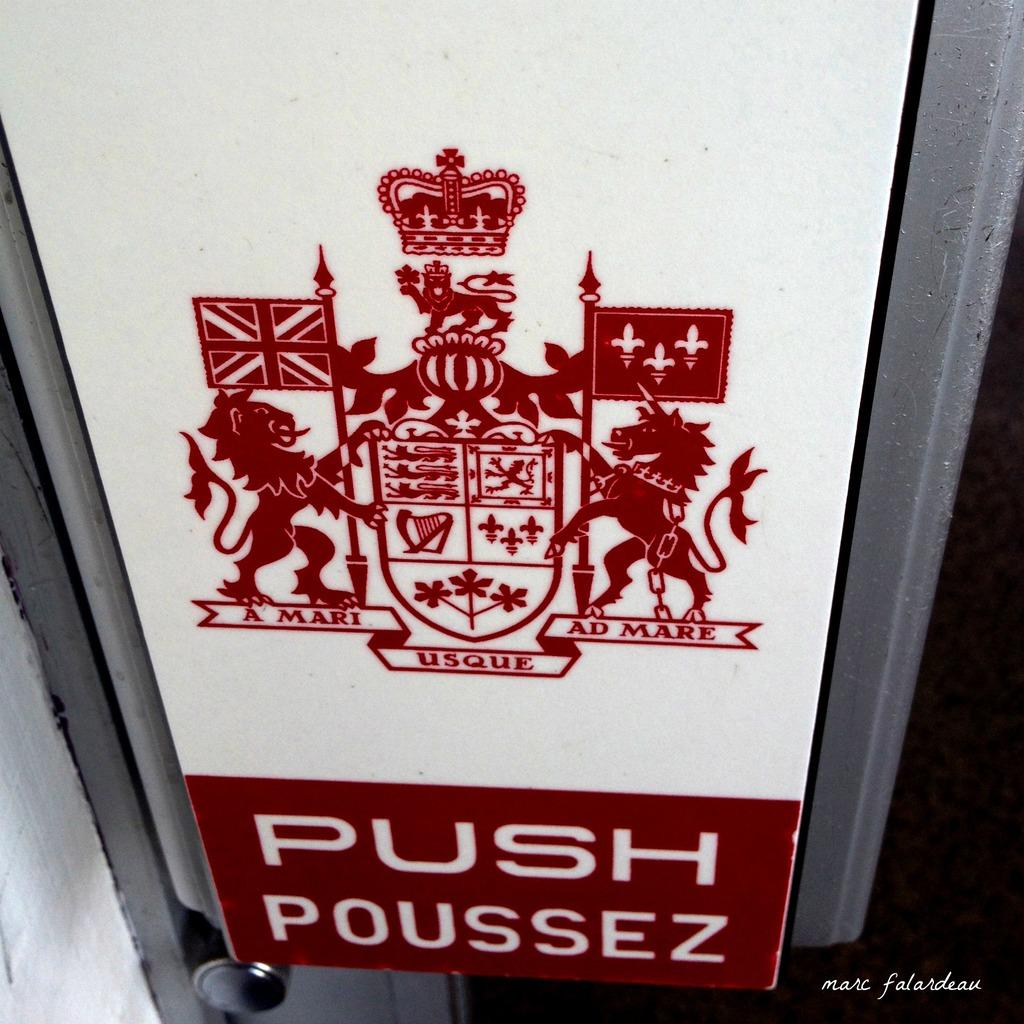<image>
Present a compact description of the photo's key features. Red and white sign with a logo and the words "Push Poussez" on the bottom. 